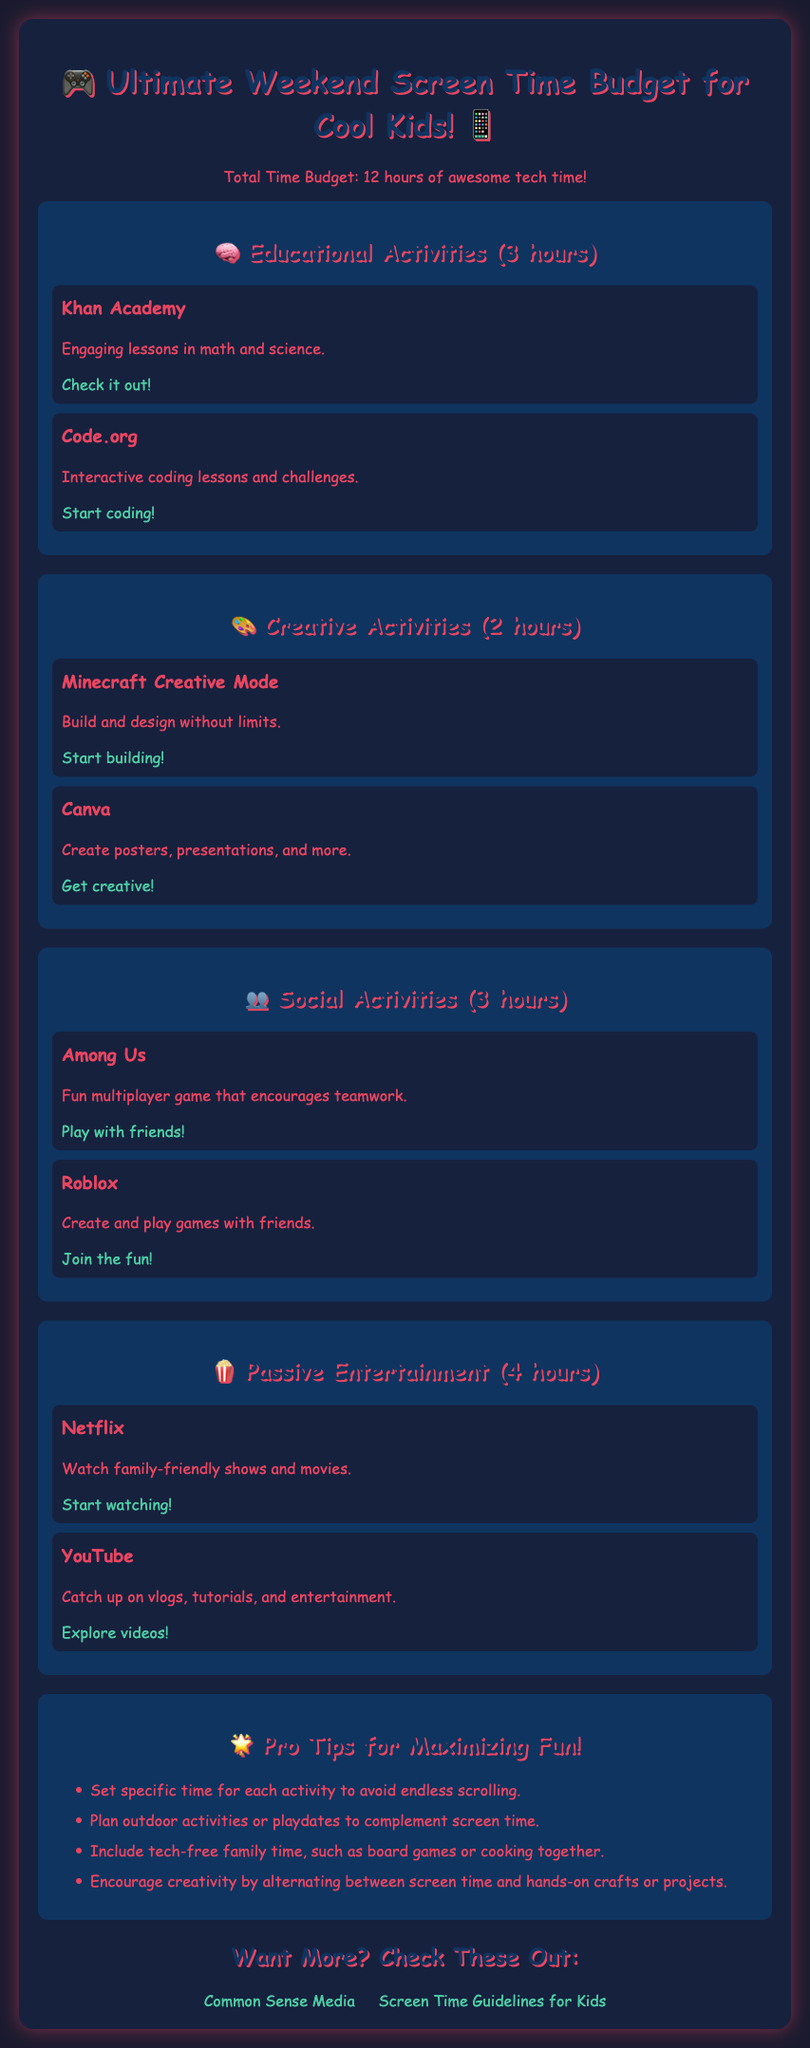What is the total time budget for weekend screen time? The total time budget is mentioned at the beginning of the document.
Answer: 12 hours How many hours are allocated for educational activities? The document specifies the hours assigned to different types of activities, including educational ones.
Answer: 3 hours Name one educational activity listed in the budget. The budget includes specific examples of activities under each category, including educational ones.
Answer: Khan Academy What type of activities are included under the "Creative Activities" section? This question asks for the category of activities listed in the document, which has specific types mentioned.
Answer: Creative Activities How many hours are dedicated to passive entertainment? The document provides a breakdown of the hours allocated to each category, including passive entertainment.
Answer: 4 hours What is one pro tip for maximizing fun with screen time? The document lists tips aimed at enhancing the experience of managing screen time.
Answer: Set specific time for each activity Which activity allows for teamwork among players? The document describes different activities, including the ones that encourage collaboration among players.
Answer: Among Us What platform is mentioned for creative projects like poster making? The document provides links to various platforms under specific activity categories, including creative projects.
Answer: Canva 